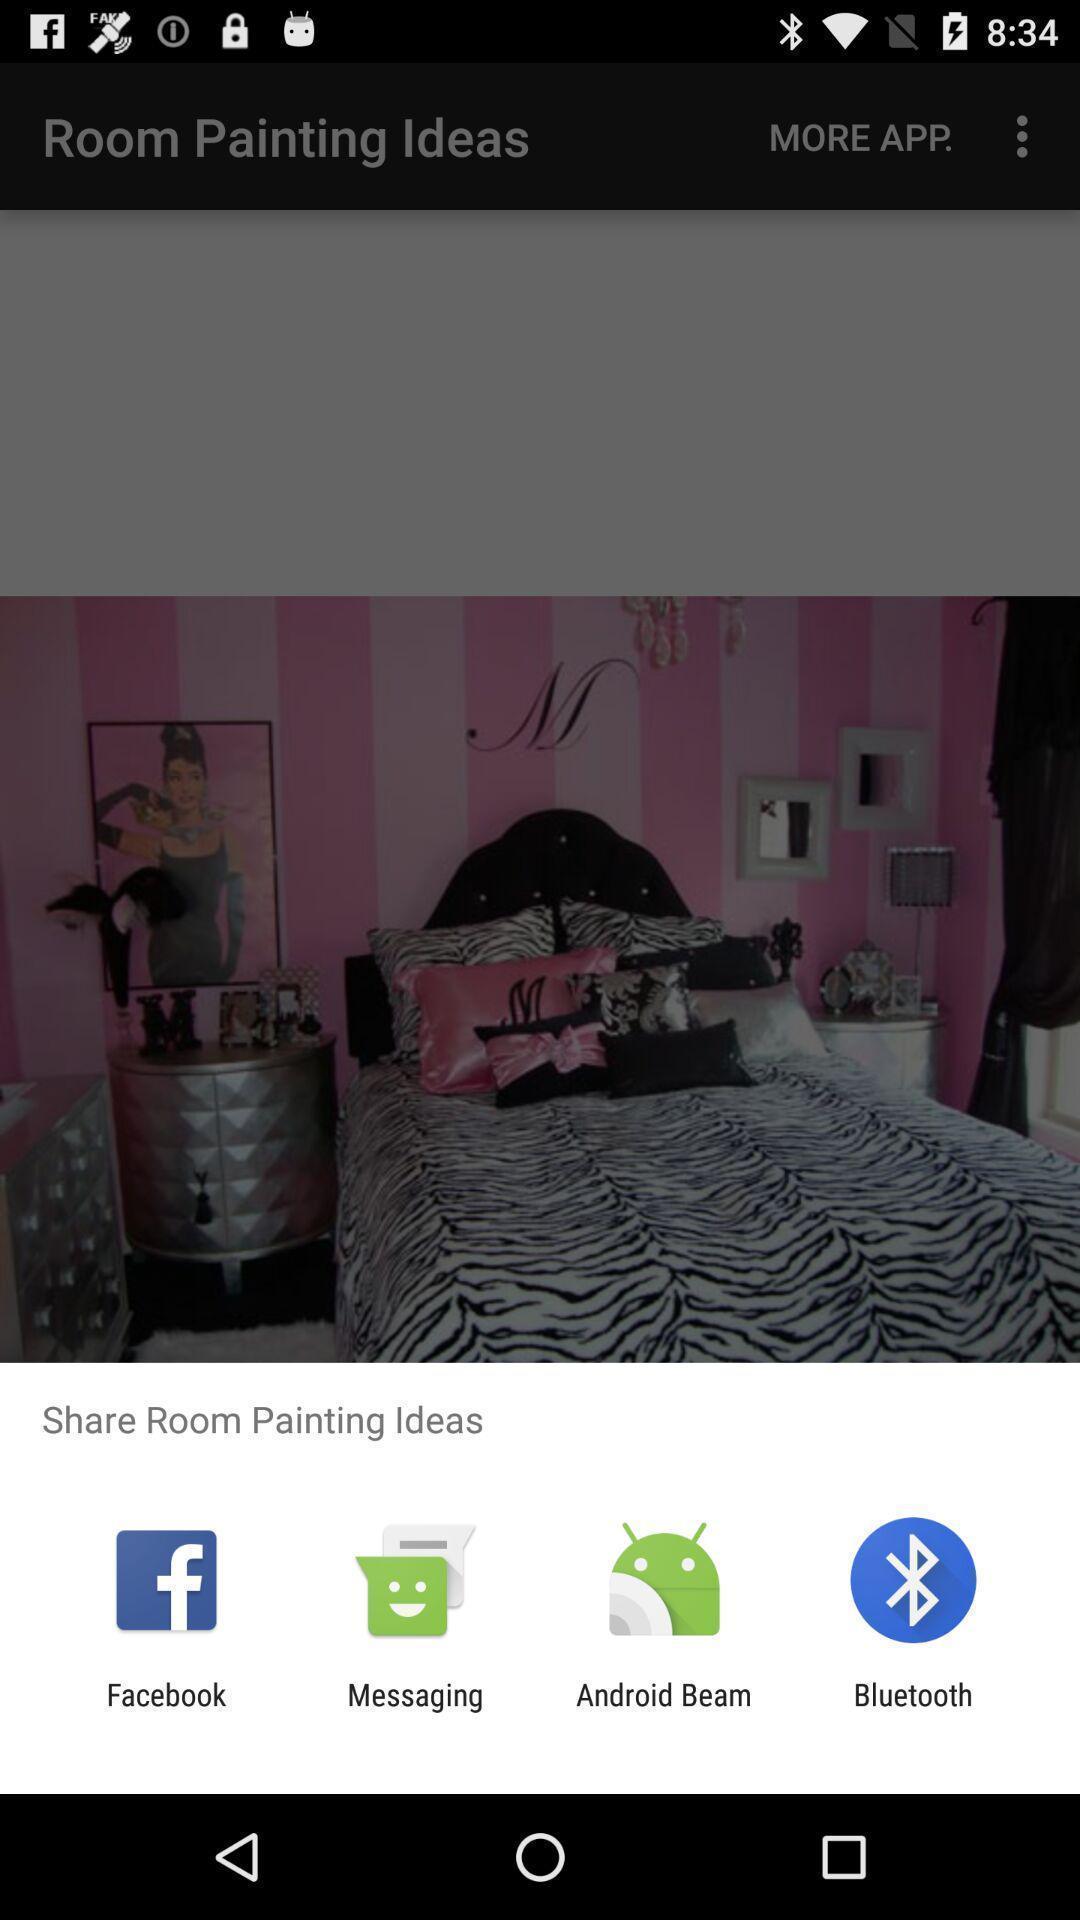What is the overall content of this screenshot? Pop up page displayed to share info through various applications. 